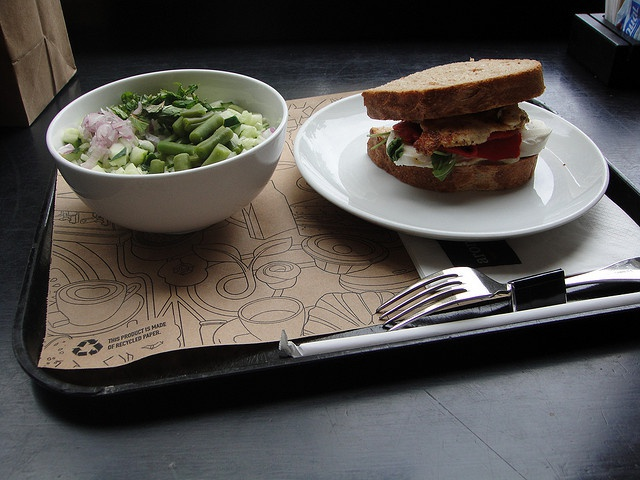Describe the objects in this image and their specific colors. I can see bowl in black, gray, darkgreen, and darkgray tones, sandwich in black, maroon, and tan tones, and fork in black, white, gray, and darkgray tones in this image. 